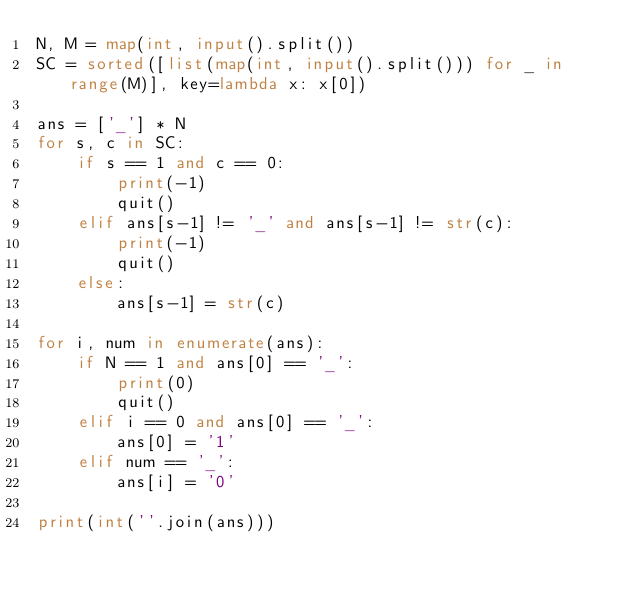Convert code to text. <code><loc_0><loc_0><loc_500><loc_500><_Python_>N, M = map(int, input().split())
SC = sorted([list(map(int, input().split())) for _ in range(M)], key=lambda x: x[0])

ans = ['_'] * N
for s, c in SC:
    if s == 1 and c == 0:
        print(-1)
        quit()
    elif ans[s-1] != '_' and ans[s-1] != str(c):
        print(-1)
        quit()
    else:
        ans[s-1] = str(c)

for i, num in enumerate(ans):
    if N == 1 and ans[0] == '_':
        print(0)
        quit()
    elif i == 0 and ans[0] == '_':
        ans[0] = '1'
    elif num == '_':
        ans[i] = '0'

print(int(''.join(ans)))</code> 